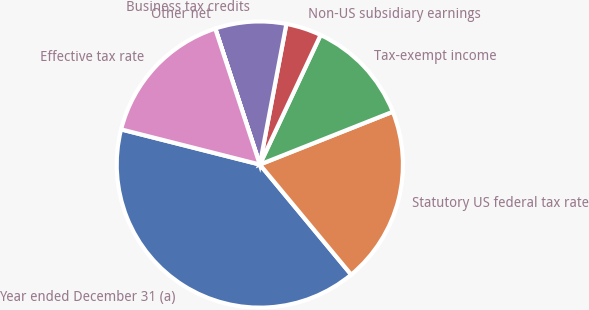Convert chart to OTSL. <chart><loc_0><loc_0><loc_500><loc_500><pie_chart><fcel>Year ended December 31 (a)<fcel>Statutory US federal tax rate<fcel>Tax-exempt income<fcel>Non-US subsidiary earnings<fcel>Business tax credits<fcel>Other net<fcel>Effective tax rate<nl><fcel>39.97%<fcel>19.99%<fcel>12.0%<fcel>4.01%<fcel>8.01%<fcel>0.01%<fcel>16.0%<nl></chart> 